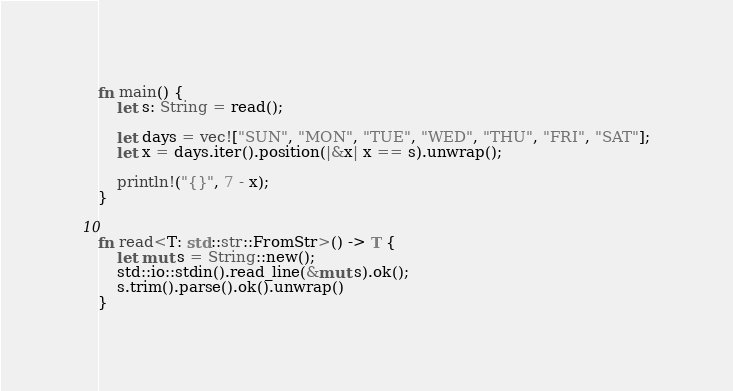Convert code to text. <code><loc_0><loc_0><loc_500><loc_500><_Rust_>fn main() {
    let s: String = read();

    let days = vec!["SUN", "MON", "TUE", "WED", "THU", "FRI", "SAT"];
    let x = days.iter().position(|&x| x == s).unwrap();

    println!("{}", 7 - x);
}


fn read<T: std::str::FromStr>() -> T {
    let mut s = String::new();
    std::io::stdin().read_line(&mut s).ok();
    s.trim().parse().ok().unwrap()
}
</code> 